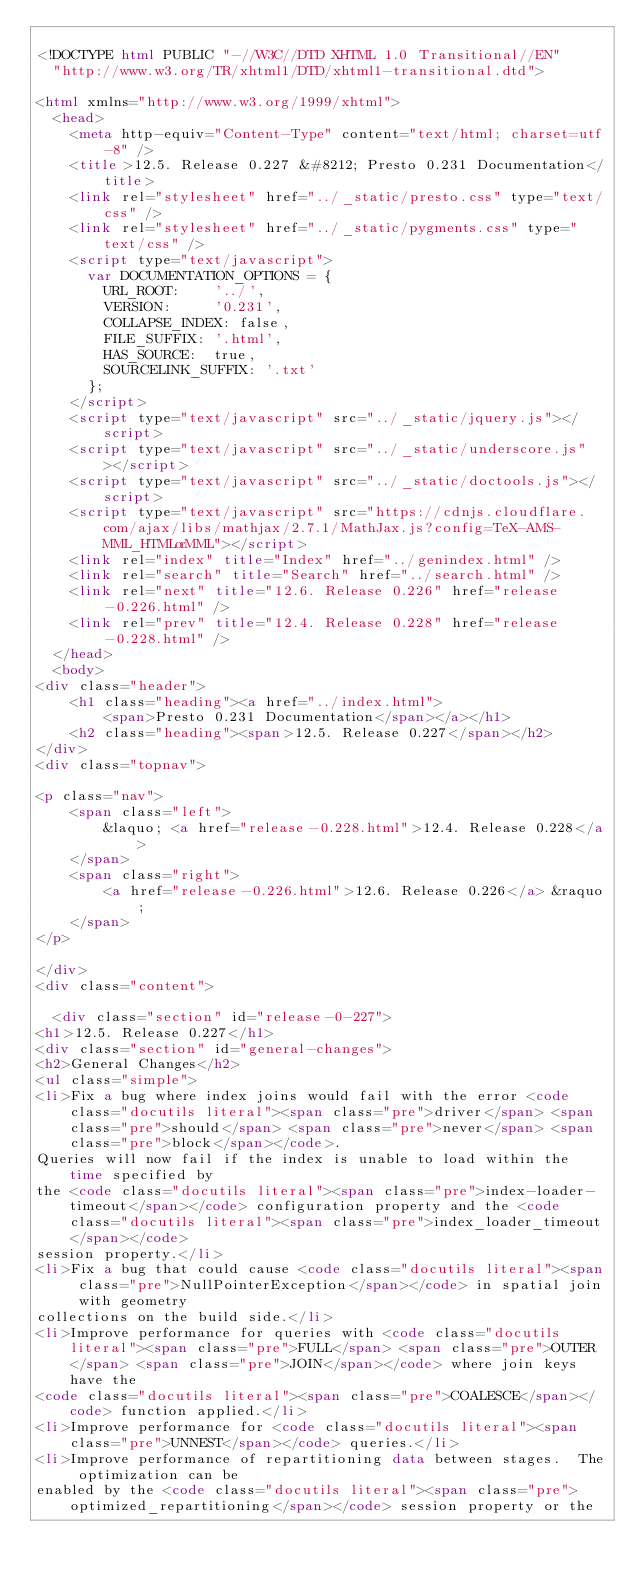Convert code to text. <code><loc_0><loc_0><loc_500><loc_500><_HTML_>
<!DOCTYPE html PUBLIC "-//W3C//DTD XHTML 1.0 Transitional//EN"
  "http://www.w3.org/TR/xhtml1/DTD/xhtml1-transitional.dtd">

<html xmlns="http://www.w3.org/1999/xhtml">
  <head>
    <meta http-equiv="Content-Type" content="text/html; charset=utf-8" />
    <title>12.5. Release 0.227 &#8212; Presto 0.231 Documentation</title>
    <link rel="stylesheet" href="../_static/presto.css" type="text/css" />
    <link rel="stylesheet" href="../_static/pygments.css" type="text/css" />
    <script type="text/javascript">
      var DOCUMENTATION_OPTIONS = {
        URL_ROOT:    '../',
        VERSION:     '0.231',
        COLLAPSE_INDEX: false,
        FILE_SUFFIX: '.html',
        HAS_SOURCE:  true,
        SOURCELINK_SUFFIX: '.txt'
      };
    </script>
    <script type="text/javascript" src="../_static/jquery.js"></script>
    <script type="text/javascript" src="../_static/underscore.js"></script>
    <script type="text/javascript" src="../_static/doctools.js"></script>
    <script type="text/javascript" src="https://cdnjs.cloudflare.com/ajax/libs/mathjax/2.7.1/MathJax.js?config=TeX-AMS-MML_HTMLorMML"></script>
    <link rel="index" title="Index" href="../genindex.html" />
    <link rel="search" title="Search" href="../search.html" />
    <link rel="next" title="12.6. Release 0.226" href="release-0.226.html" />
    <link rel="prev" title="12.4. Release 0.228" href="release-0.228.html" /> 
  </head>
  <body>
<div class="header">
    <h1 class="heading"><a href="../index.html">
        <span>Presto 0.231 Documentation</span></a></h1>
    <h2 class="heading"><span>12.5. Release 0.227</span></h2>
</div>
<div class="topnav">
    
<p class="nav">
    <span class="left">
        &laquo; <a href="release-0.228.html">12.4. Release 0.228</a>
    </span>
    <span class="right">
        <a href="release-0.226.html">12.6. Release 0.226</a> &raquo;
    </span>
</p>

</div>
<div class="content">
    
  <div class="section" id="release-0-227">
<h1>12.5. Release 0.227</h1>
<div class="section" id="general-changes">
<h2>General Changes</h2>
<ul class="simple">
<li>Fix a bug where index joins would fail with the error <code class="docutils literal"><span class="pre">driver</span> <span class="pre">should</span> <span class="pre">never</span> <span class="pre">block</span></code>.
Queries will now fail if the index is unable to load within the time specified by
the <code class="docutils literal"><span class="pre">index-loader-timeout</span></code> configuration property and the <code class="docutils literal"><span class="pre">index_loader_timeout</span></code>
session property.</li>
<li>Fix a bug that could cause <code class="docutils literal"><span class="pre">NullPointerException</span></code> in spatial join with geometry
collections on the build side.</li>
<li>Improve performance for queries with <code class="docutils literal"><span class="pre">FULL</span> <span class="pre">OUTER</span> <span class="pre">JOIN</span></code> where join keys have the
<code class="docutils literal"><span class="pre">COALESCE</span></code> function applied.</li>
<li>Improve performance for <code class="docutils literal"><span class="pre">UNNEST</span></code> queries.</li>
<li>Improve performance of repartitioning data between stages.  The optimization can be
enabled by the <code class="docutils literal"><span class="pre">optimized_repartitioning</span></code> session property or the</code> 